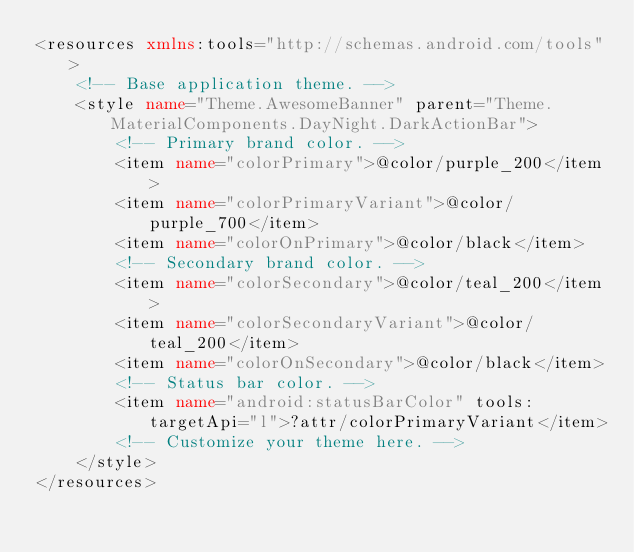Convert code to text. <code><loc_0><loc_0><loc_500><loc_500><_XML_><resources xmlns:tools="http://schemas.android.com/tools">
    <!-- Base application theme. -->
    <style name="Theme.AwesomeBanner" parent="Theme.MaterialComponents.DayNight.DarkActionBar">
        <!-- Primary brand color. -->
        <item name="colorPrimary">@color/purple_200</item>
        <item name="colorPrimaryVariant">@color/purple_700</item>
        <item name="colorOnPrimary">@color/black</item>
        <!-- Secondary brand color. -->
        <item name="colorSecondary">@color/teal_200</item>
        <item name="colorSecondaryVariant">@color/teal_200</item>
        <item name="colorOnSecondary">@color/black</item>
        <!-- Status bar color. -->
        <item name="android:statusBarColor" tools:targetApi="l">?attr/colorPrimaryVariant</item>
        <!-- Customize your theme here. -->
    </style>
</resources></code> 